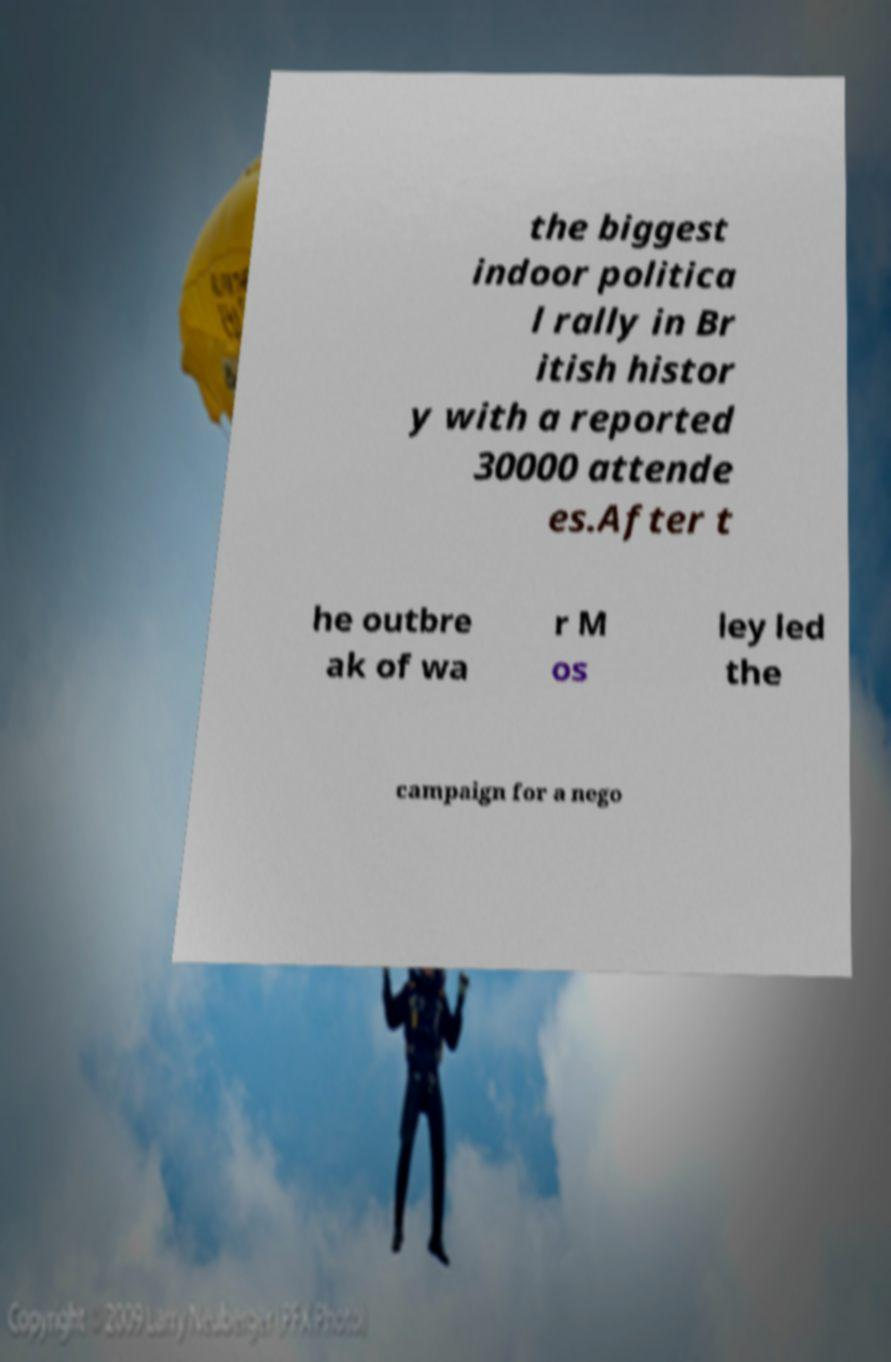Could you extract and type out the text from this image? the biggest indoor politica l rally in Br itish histor y with a reported 30000 attende es.After t he outbre ak of wa r M os ley led the campaign for a nego 